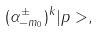<formula> <loc_0><loc_0><loc_500><loc_500>( \alpha ^ { \pm } _ { - m _ { 0 } } ) ^ { k } | p > ,</formula> 